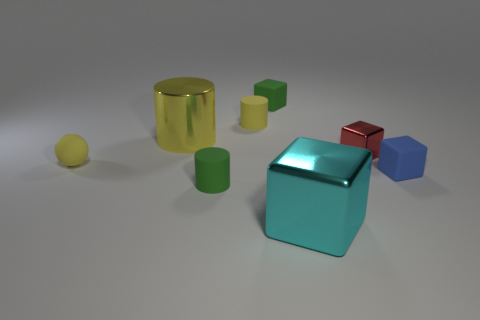What materials do these objects appear to be made of? The objects in the image seem to have varying textures indicating different materials. The big cylinder and tiny sphere look shiny and perhaps metallic, while the cubes and other cylinders have a matte finish, possibly indicating a plastic or painted wood material. Do the objects appear solid or hollow? Based on their shapes and shadows, all the objects in the image appear to be solid. However, without more information or the ability to inspect them physically, it's not possible to determine the internal structure for certain. 